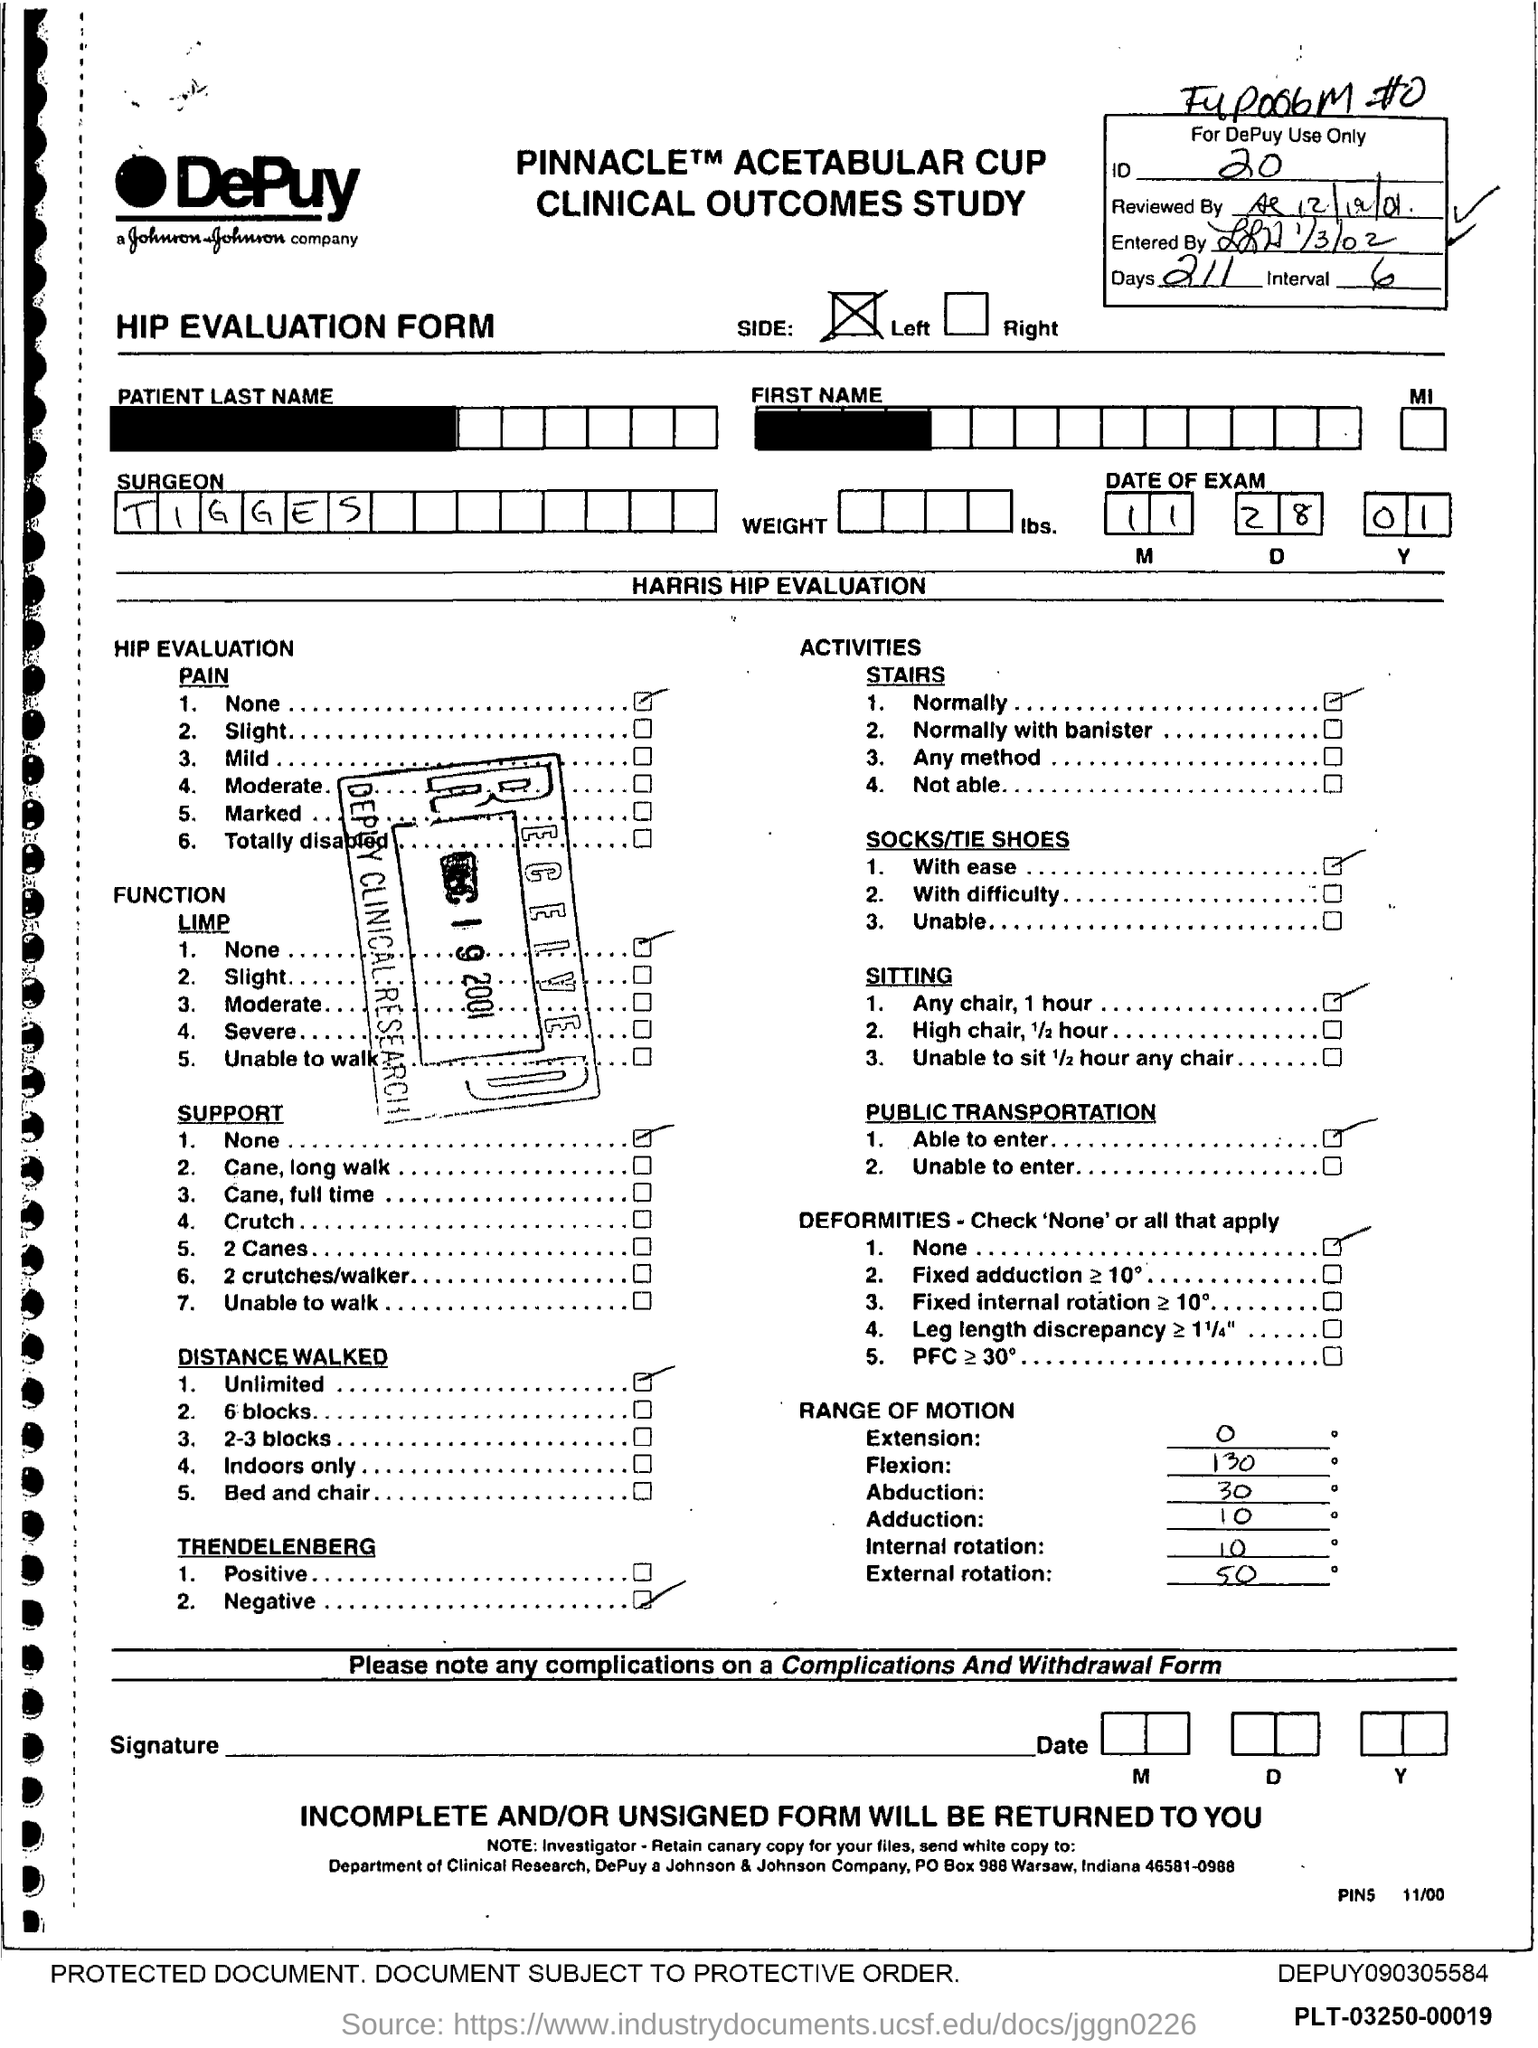Point out several critical features in this image. The number of days is 211. The surgeon's name is Tigges. The ID Number is 20.. 